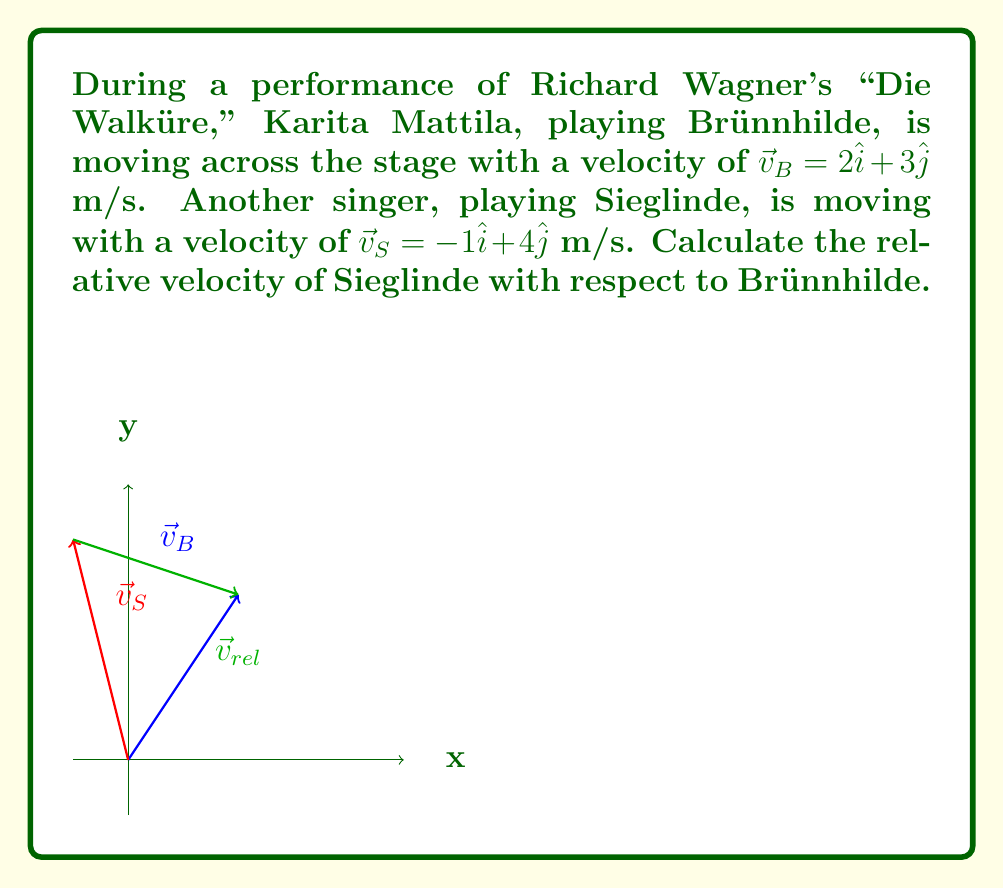Could you help me with this problem? To find the relative velocity of Sieglinde with respect to Brünnhilde, we need to subtract Brünnhilde's velocity from Sieglinde's velocity. This is because relative velocity is defined as the velocity of one object as seen from the perspective of another object.

Let's follow these steps:

1) We have:
   $\vec{v}_B = 2\hat{i} + 3\hat{j}$ (Brünnhilde's velocity)
   $\vec{v}_S = -1\hat{i} + 4\hat{j}$ (Sieglinde's velocity)

2) The relative velocity $\vec{v}_{rel}$ is given by:
   $\vec{v}_{rel} = \vec{v}_S - \vec{v}_B$

3) Let's subtract the components:
   $\vec{v}_{rel} = (-1\hat{i} + 4\hat{j}) - (2\hat{i} + 3\hat{j})$

4) Simplify:
   $\vec{v}_{rel} = (-1\hat{i} + 4\hat{j}) + (-2\hat{i} - 3\hat{j})$
   $\vec{v}_{rel} = (-1-2)\hat{i} + (4-3)\hat{j}$
   $\vec{v}_{rel} = -3\hat{i} + \hat{j}$

Therefore, the relative velocity of Sieglinde with respect to Brünnhilde is $-3\hat{i} + \hat{j}$ m/s.
Answer: $-3\hat{i} + \hat{j}$ m/s 